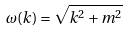Convert formula to latex. <formula><loc_0><loc_0><loc_500><loc_500>\omega ( { k } ) = \sqrt { { k } ^ { 2 } + m ^ { 2 } }</formula> 